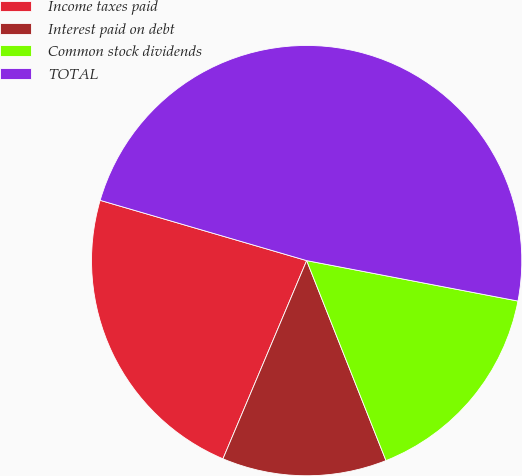<chart> <loc_0><loc_0><loc_500><loc_500><pie_chart><fcel>Income taxes paid<fcel>Interest paid on debt<fcel>Common stock dividends<fcel>TOTAL<nl><fcel>23.16%<fcel>12.37%<fcel>15.98%<fcel>48.49%<nl></chart> 